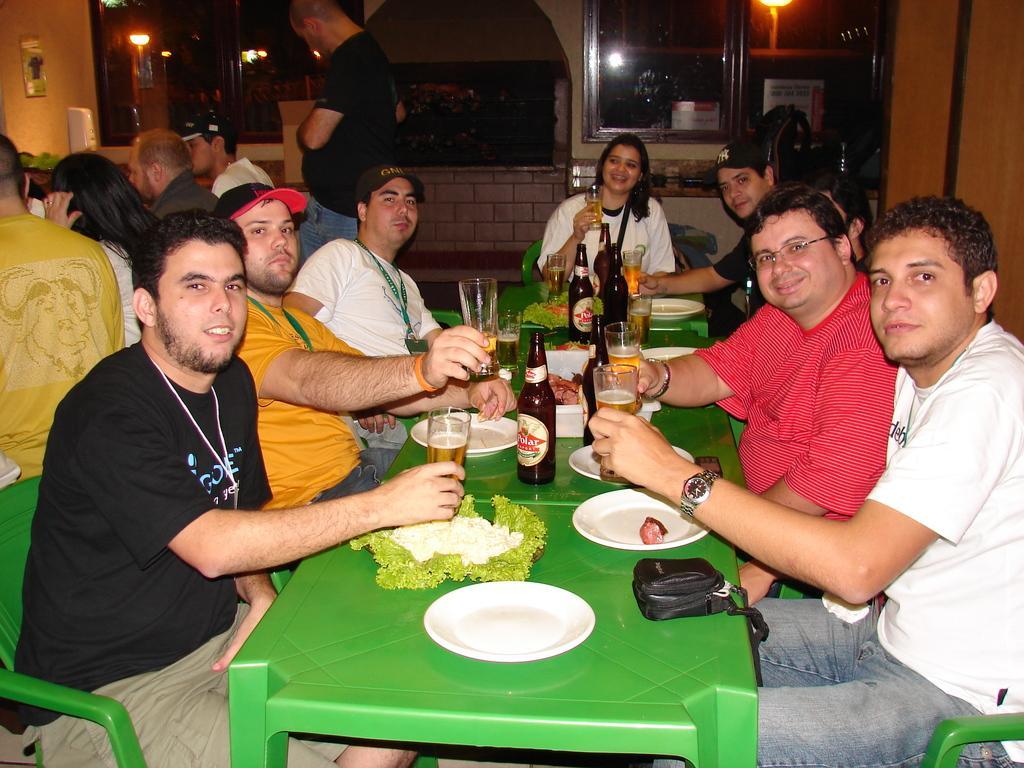Please provide a concise description of this image. Here we can see a group of people sitting on chairs in front of table with plates, glasses and bottles of beers in front of them 